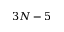<formula> <loc_0><loc_0><loc_500><loc_500>3 N - 5</formula> 